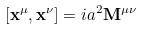<formula> <loc_0><loc_0><loc_500><loc_500>[ { \mathbf x } ^ { \mu } , { \mathbf x } ^ { \nu } ] = i a ^ { 2 } { \mathbf M } ^ { \mu \nu }</formula> 